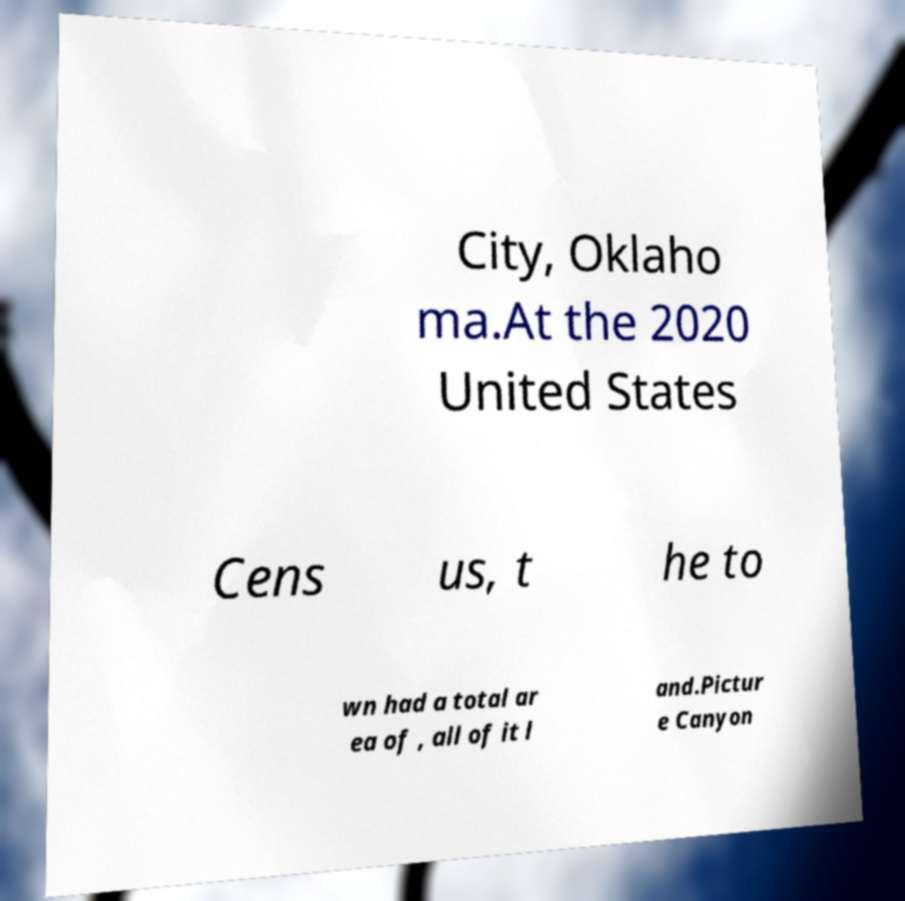Please read and relay the text visible in this image. What does it say? City, Oklaho ma.At the 2020 United States Cens us, t he to wn had a total ar ea of , all of it l and.Pictur e Canyon 